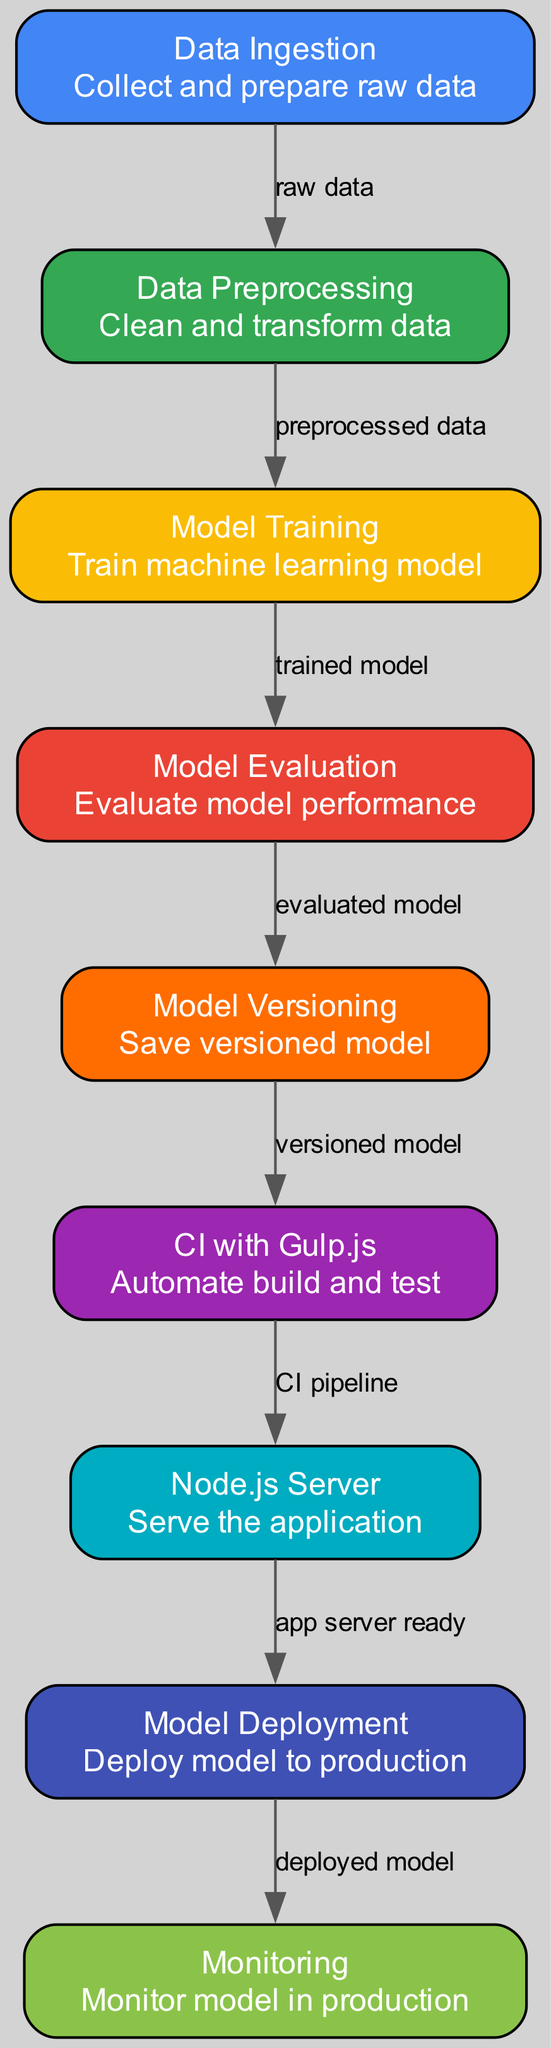What is the first stage in the deployment pipeline? The first stage is "Data Ingestion," which is responsible for collecting and preparing raw data.
Answer: Data Ingestion How many nodes are present in the diagram? By counting the nodes listed in the diagram, there are a total of 9 nodes, including stages from data ingestion to monitoring.
Answer: 9 What follows model training in the pipeline? Following model training according to the directed flow of the diagram is "Model Evaluation," where the model's performance is evaluated.
Answer: Model Evaluation What is the purpose of the CI with Gulp.js node? The CI with Gulp.js node automates the build and test processes, integrating changes into the deployment pipeline continuously.
Answer: Automate build and test Which node triggers the model deployment? The node that triggers the model deployment is the "Node.js Server," indicating that the application server is ready to deploy the model.
Answer: Node.js Server How does the data flow from data preprocessing to model training? The data flows from "Data Preprocessing" to "Model Training" by sending the preprocessed data to train the machine learning model.
Answer: Preprocessed data What type of monitoring occurs after model deployment? After model deployment, "Monitoring" occurs to keep track of the model's performance in the production environment.
Answer: Monitor model in production Which node is responsible for saving versioned models? The "Model Versioning" node is specifically responsible for saving the versioned models after evaluation.
Answer: Model Versioning What comes directly after model evaluation in the pipeline? Directly after model evaluation is the "Model Versioning" stage, where the evaluated models are saved in versioned formats.
Answer: Model Versioning 